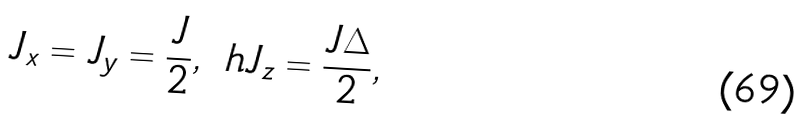<formula> <loc_0><loc_0><loc_500><loc_500>J _ { x } = J _ { y } = \frac { J } { 2 } , \ h J _ { z } = \frac { J \Delta } { 2 } ,</formula> 